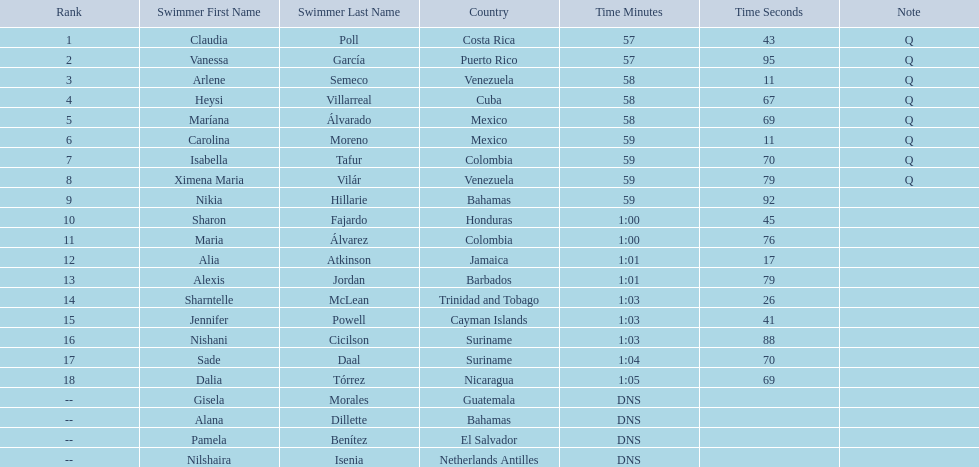Who was the only cuban to finish in the top eight? Heysi Villarreal. 